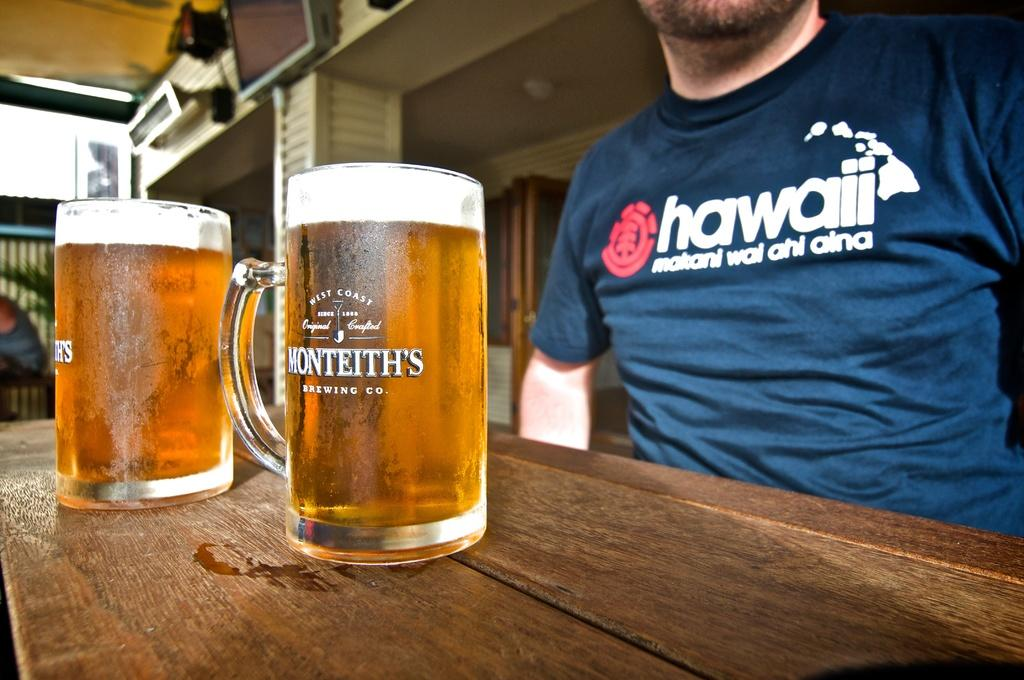<image>
Present a compact description of the photo's key features. A man wearing a Hawaii shirt sits in front of two mugs of beer. 